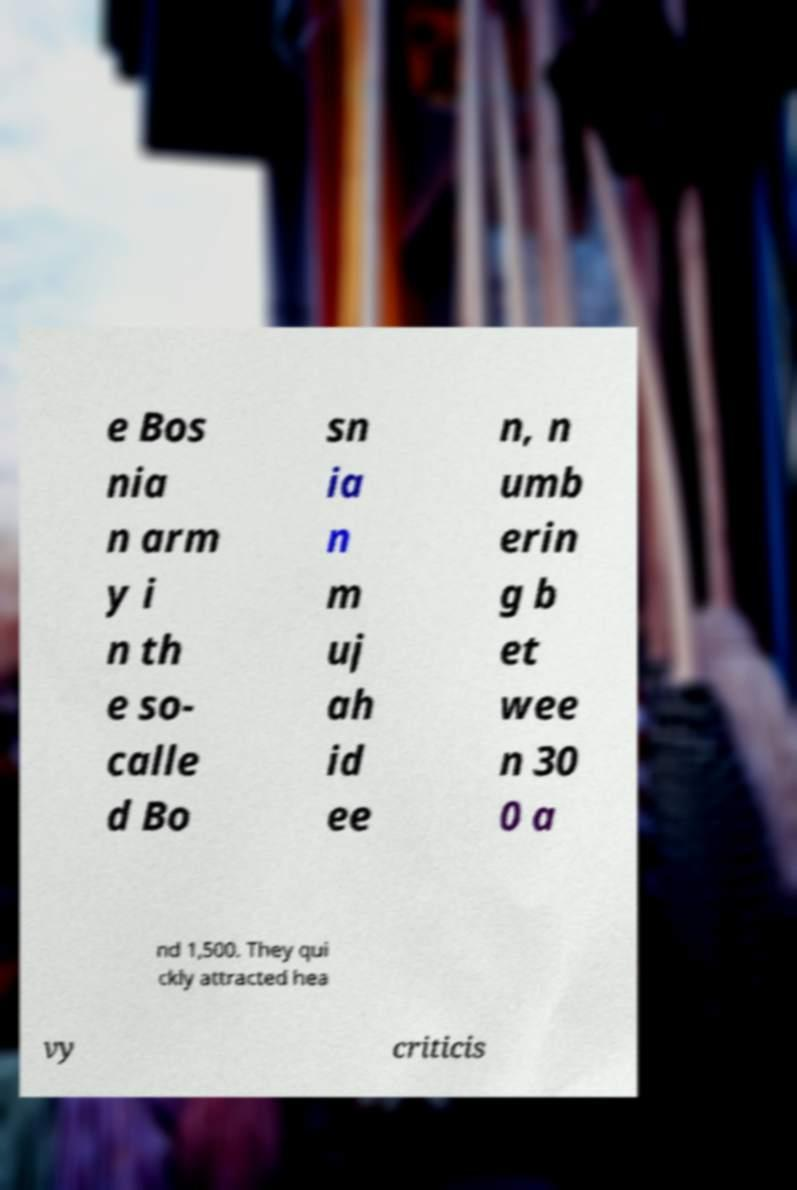Can you read and provide the text displayed in the image?This photo seems to have some interesting text. Can you extract and type it out for me? e Bos nia n arm y i n th e so- calle d Bo sn ia n m uj ah id ee n, n umb erin g b et wee n 30 0 a nd 1,500. They qui ckly attracted hea vy criticis 